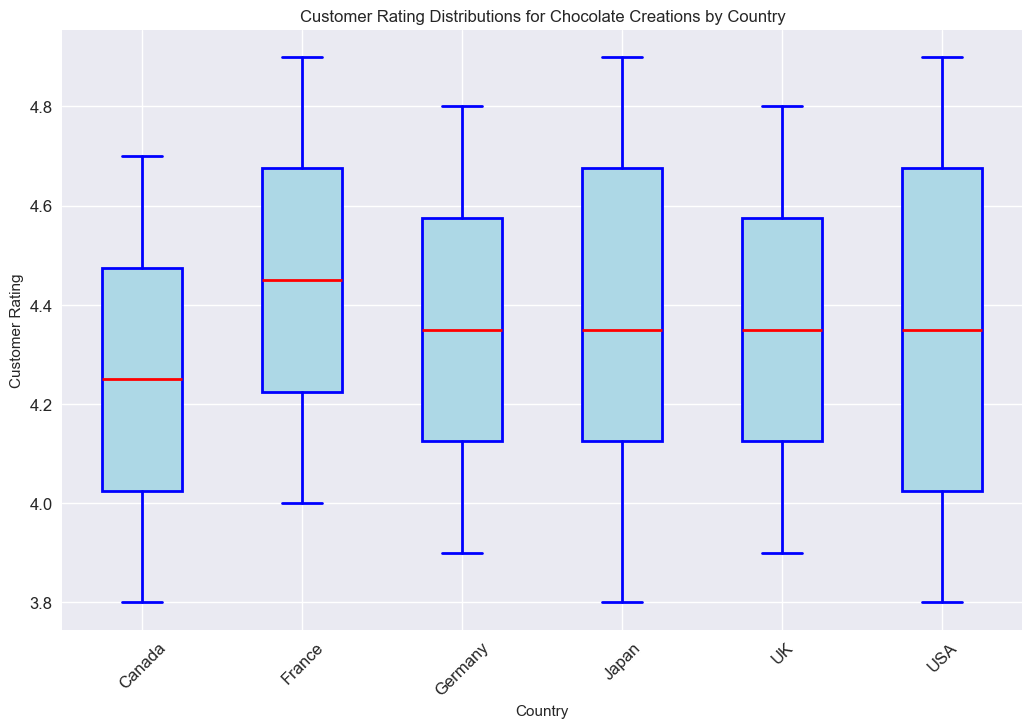Which country has the highest median customer rating? To identify the country with the highest median rating, look at the bold horizontal lines within each box, which represent the median values in the box plot. The highest median value appears to be around 4.8.
Answer: France and Japan Which country has the widest range of customer ratings? The range is determined by the distance between the lower whisker and the upper whisker. The USA has the widest range because its whiskers cover a broader span of ratings.
Answer: USA What's the interquartile range (IQR) of customer ratings for France? The IQR is the difference between the third quartile (Q3) and the first quartile (Q1) of the box. For France, Q3 is approximately 4.8 and Q1 is about 4.2. Calculating the difference gives 4.8 - 4.2.
Answer: 0.6 How do the medians of customer ratings in the USA and Canada compare? Compare the bold horizontal lines in the boxes for USA and Canada. The median for the USA is slightly lower than that of Canada.
Answer: USA < Canada Which country has the smallest interquartile range of customer ratings? The country with the smallest IQR will have the narrowest box. All boxes are similar in width except for USA and Japan. France has a slightly narrower box, indicating a smaller IQR.
Answer: France What is the maximum customer rating given in the UK? The maximum rating is indicated by the upper whisker. For the UK, the upper whisker reaches up to 4.8.
Answer: 4.8 For which country are there no ratings below 4.0? Look for countries whose lower whisker does not extend below the 4.0 mark. France and Japan's lower whiskers do not go below the 4.0 value.
Answer: France and Japan Compare the median customer ratings of Germany and the UK. The medians are represented by the bold horizontal lines in the boxes. Both countries appear to have similar median ratings around 4.4 or 4.5.
Answer: Similar Which country's customer ratings vary the least? The box with the smallest range (shorter whiskers and narrower box) indicates the least variation. France shows the smallest range and variation in ratings.
Answer: France 